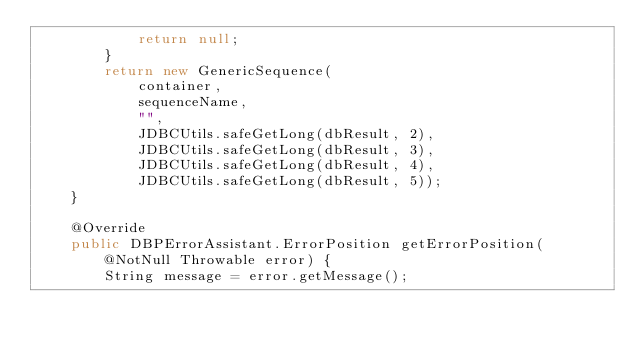<code> <loc_0><loc_0><loc_500><loc_500><_Java_>            return null;
        }
        return new GenericSequence(
            container,
            sequenceName,
            "",
            JDBCUtils.safeGetLong(dbResult, 2),
            JDBCUtils.safeGetLong(dbResult, 3),
            JDBCUtils.safeGetLong(dbResult, 4),
            JDBCUtils.safeGetLong(dbResult, 5));
    }

    @Override
    public DBPErrorAssistant.ErrorPosition getErrorPosition(@NotNull Throwable error) {
        String message = error.getMessage();</code> 